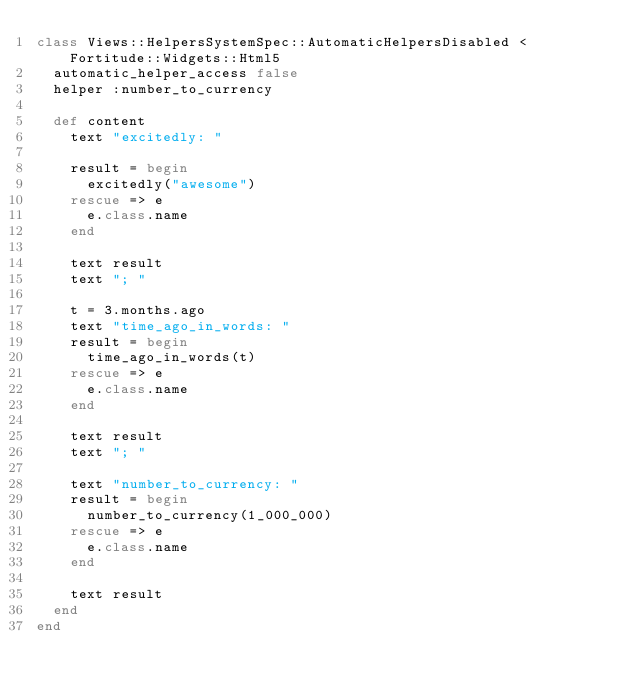Convert code to text. <code><loc_0><loc_0><loc_500><loc_500><_Ruby_>class Views::HelpersSystemSpec::AutomaticHelpersDisabled < Fortitude::Widgets::Html5
  automatic_helper_access false
  helper :number_to_currency

  def content
    text "excitedly: "

    result = begin
      excitedly("awesome")
    rescue => e
      e.class.name
    end

    text result
    text "; "

    t = 3.months.ago
    text "time_ago_in_words: "
    result = begin
      time_ago_in_words(t)
    rescue => e
      e.class.name
    end

    text result
    text "; "

    text "number_to_currency: "
    result = begin
      number_to_currency(1_000_000)
    rescue => e
      e.class.name
    end

    text result
  end
end
</code> 